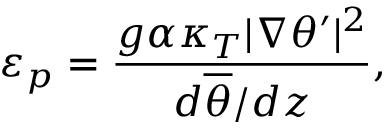Convert formula to latex. <formula><loc_0><loc_0><loc_500><loc_500>\varepsilon _ { p } = \frac { g \alpha \kappa _ { T } | \nabla \theta ^ { \prime } | ^ { 2 } } { d \overline { \theta } / d z } ,</formula> 